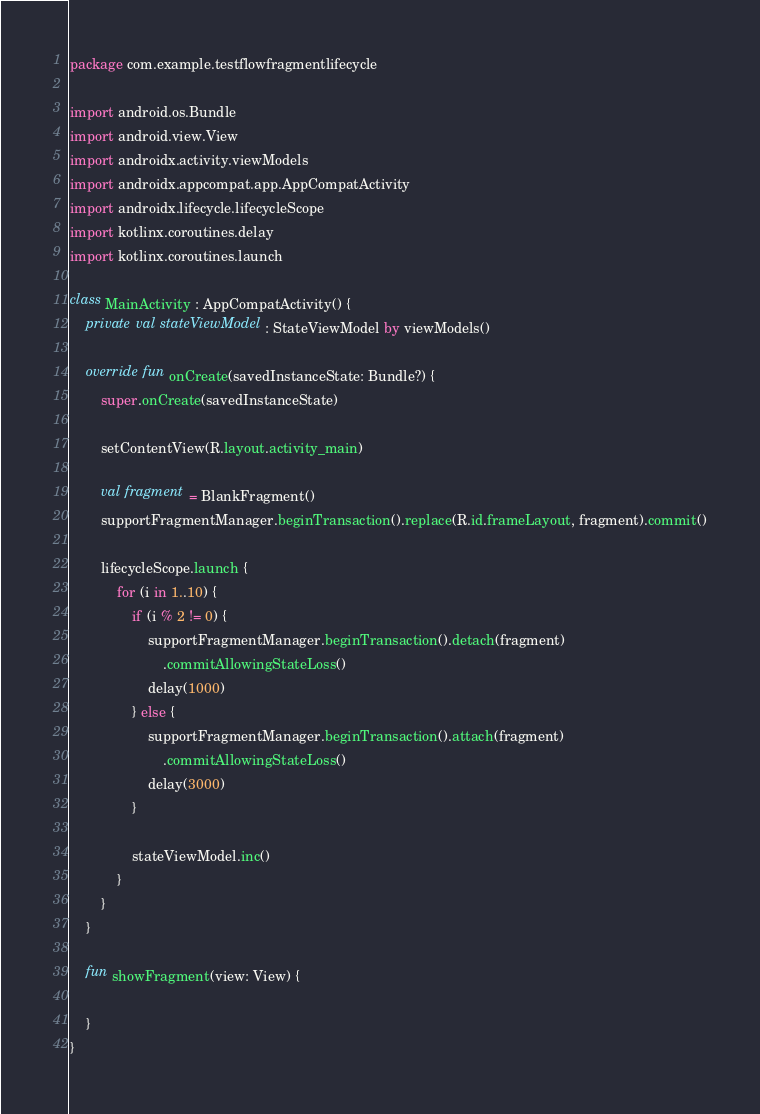Convert code to text. <code><loc_0><loc_0><loc_500><loc_500><_Kotlin_>package com.example.testflowfragmentlifecycle

import android.os.Bundle
import android.view.View
import androidx.activity.viewModels
import androidx.appcompat.app.AppCompatActivity
import androidx.lifecycle.lifecycleScope
import kotlinx.coroutines.delay
import kotlinx.coroutines.launch

class MainActivity : AppCompatActivity() {
    private val stateViewModel: StateViewModel by viewModels()

    override fun onCreate(savedInstanceState: Bundle?) {
        super.onCreate(savedInstanceState)

        setContentView(R.layout.activity_main)

        val fragment = BlankFragment()
        supportFragmentManager.beginTransaction().replace(R.id.frameLayout, fragment).commit()

        lifecycleScope.launch {
            for (i in 1..10) {
                if (i % 2 != 0) {
                    supportFragmentManager.beginTransaction().detach(fragment)
                        .commitAllowingStateLoss()
                    delay(1000)
                } else {
                    supportFragmentManager.beginTransaction().attach(fragment)
                        .commitAllowingStateLoss()
                    delay(3000)
                }

                stateViewModel.inc()
            }
        }
    }

    fun showFragment(view: View) {

    }
}</code> 